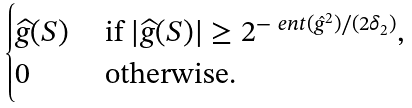Convert formula to latex. <formula><loc_0><loc_0><loc_500><loc_500>\begin{cases} \widehat { g } ( S ) & \text { if } | \widehat { g } ( S ) | \geq 2 ^ { - \ e n t ( \hat { g } ^ { 2 } ) / ( 2 \delta _ { 2 } ) } , \\ 0 & \text { otherwise. } \end{cases}</formula> 